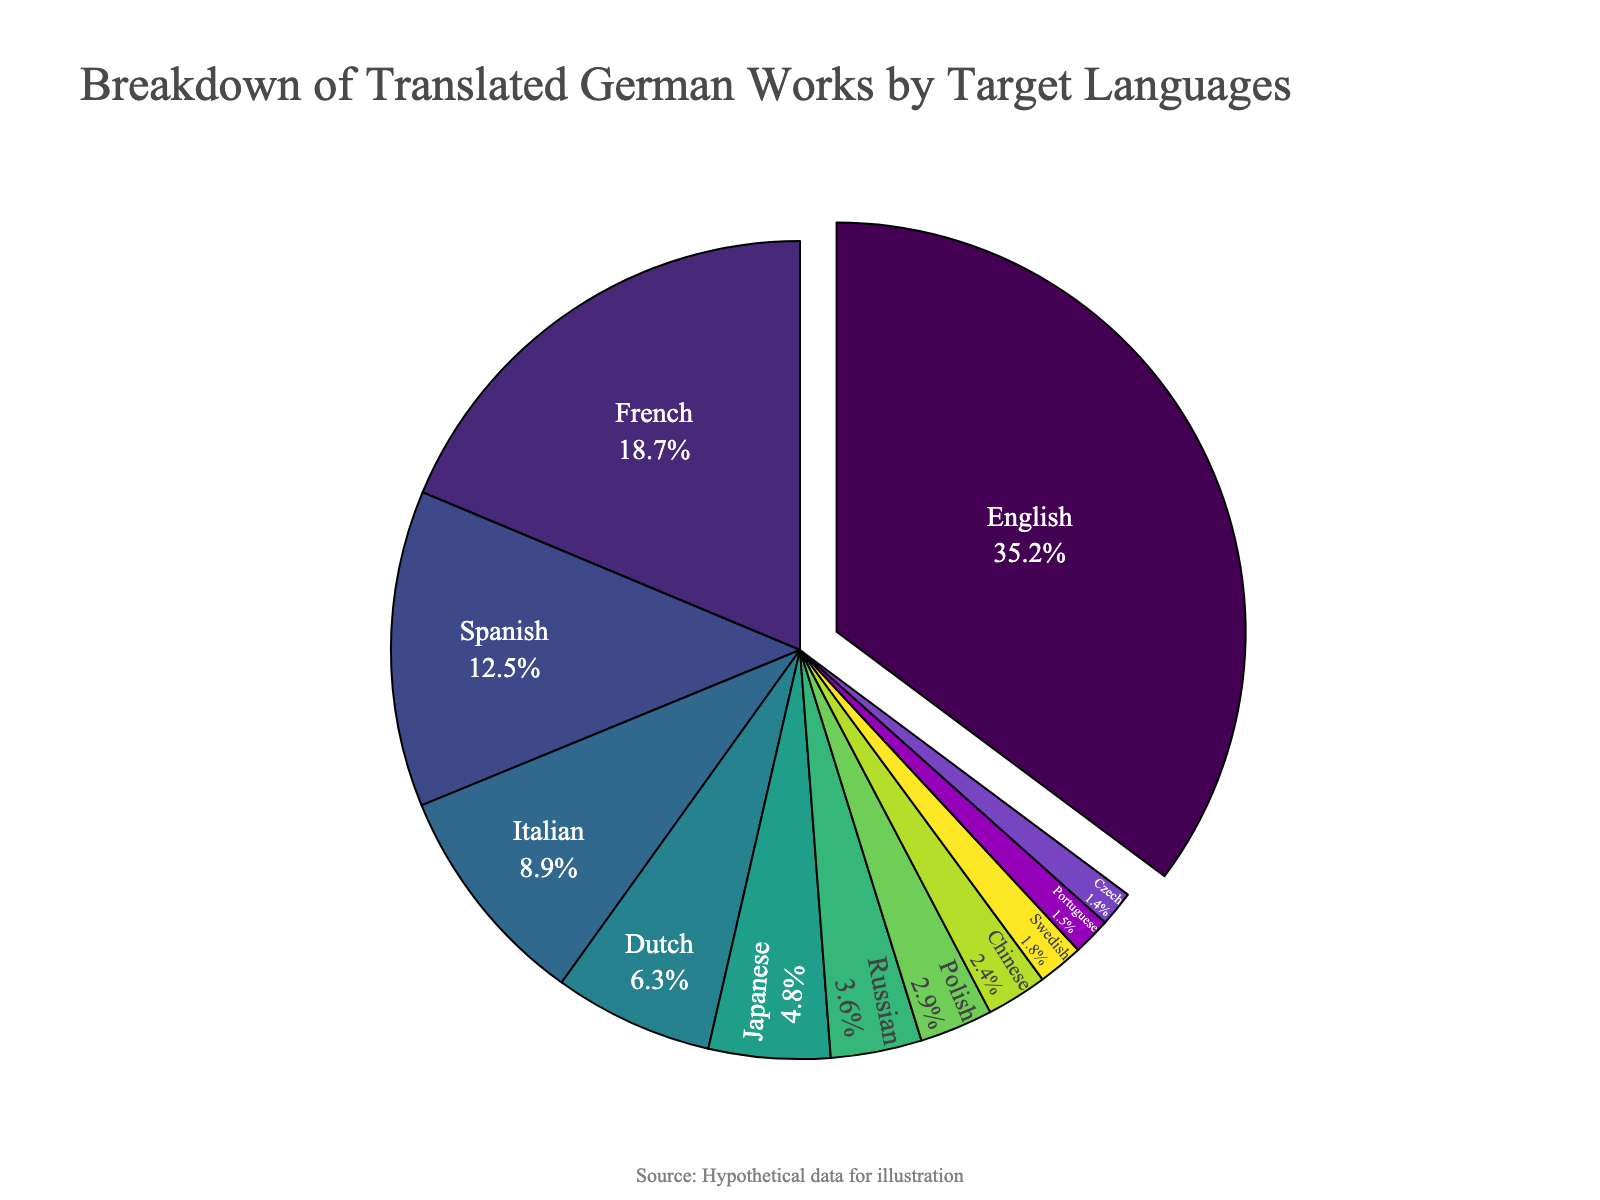what percentage of translated German works are in English and French combined? First, find the percentage for English which is 35.2%, then find the percentage for French which is 18.7%, add them together: 35.2 + 18.7 = 53.9%
Answer: 53.9% Which target language has the smallest share of translated German works? The target language with the smallest share has the lowest percentage. From the data, it is Czech with 1.4%
Answer: Czech Which target language has a higher percentage of translated German works, Japanese or Dutch? Japanese has 4.8% while Dutch has 6.3%. Comparing 4.8 and 6.3, Dutch has a higher percentage
Answer: Dutch Compare the percentage of translated German works in Italian and Spanish. Which one is greater and by how much? Italian has 8.9% and Spanish has 12.5%. To find out which one is greater and by how much, subtract: 12.5 - 8.9 = 3.6%. Spanish is greater by 3.6%
Answer: Spanish by 3.6% How does the sum of percentages for Polish, Chinese, and Swedish compare to that of Spanish? Sum percentages for Polish (2.9%), Chinese (2.4%), and Swedish (1.8%): 2.9 + 2.4 + 1.8 = 7.1%. Compare it with Spanish (12.5%): 7.1 < 12.5
Answer: Spanish How many target languages have a percentage greater than 5%? From the data, the languages are English (35.2%), French (18.7%), Spanish (12.5%), and Dutch (6.3%). There are 4 languages in total
Answer: 4 What is the combined percentage of the three smallest segments? The three smallest segments are Czech (1.4%), Portuguese (1.5%), and Swedish (1.8%). Sum these percentages: 1.4 + 1.5 + 1.8 = 4.7%
Answer: 4.7% Which language represents the largest segment, and how much larger is it than Russian? English represents the largest segment with 35.2%. Russian has 3.6%. Find the difference: 35.2 - 3.6 = 31.6%
Answer: English by 31.6% What are the colors used to represent the top three target languages, and how can they be identified visually? The top three languages are English, French, and Spanish. They are represented by the largest segments in the pie chart. The exact colors depend on the Viridis color scale used, which typically ranges from yellow to blue. Identify these colors from the chart visually.
Answer: Yellow to green (depending on exact colors) 